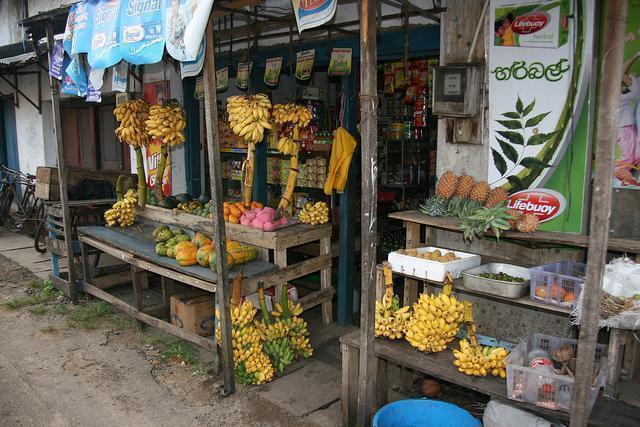What is the brand Lifebuoy selling?
Choose the right answer from the provided options to respond to the question.
Options: Clothing, shampoo, soap, backpacks. Soap. 